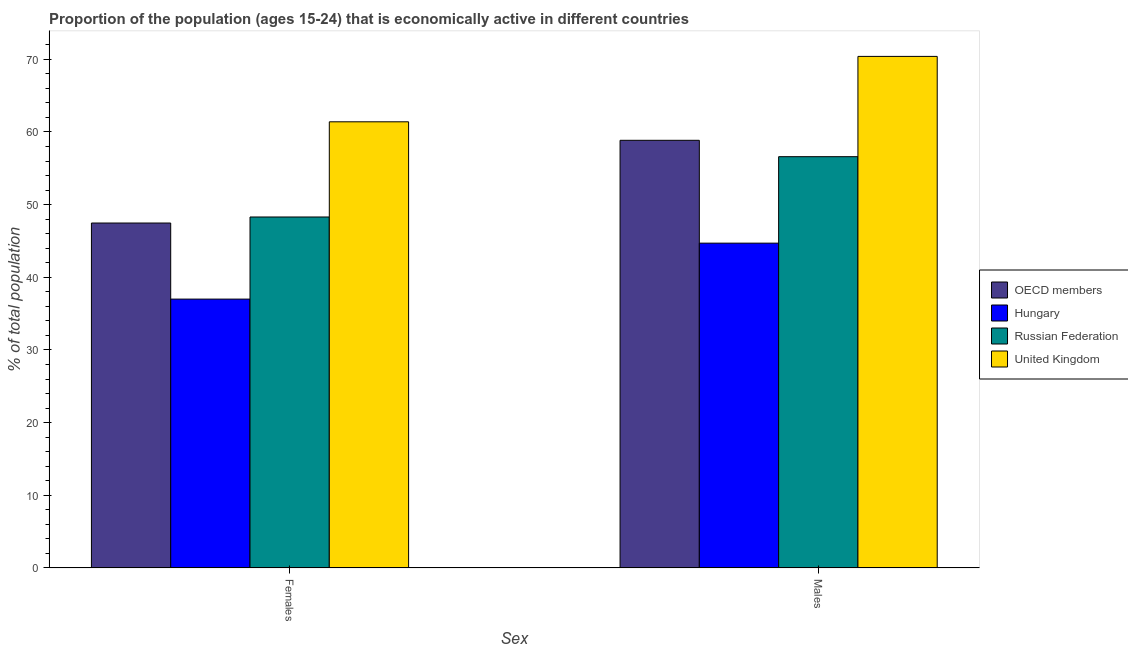How many different coloured bars are there?
Your answer should be very brief. 4. Are the number of bars per tick equal to the number of legend labels?
Keep it short and to the point. Yes. Are the number of bars on each tick of the X-axis equal?
Offer a very short reply. Yes. How many bars are there on the 1st tick from the left?
Keep it short and to the point. 4. What is the label of the 1st group of bars from the left?
Offer a terse response. Females. What is the percentage of economically active male population in OECD members?
Make the answer very short. 58.85. Across all countries, what is the maximum percentage of economically active male population?
Your answer should be very brief. 70.4. In which country was the percentage of economically active female population minimum?
Provide a succinct answer. Hungary. What is the total percentage of economically active female population in the graph?
Your response must be concise. 194.17. What is the difference between the percentage of economically active female population in Russian Federation and that in Hungary?
Ensure brevity in your answer.  11.3. What is the difference between the percentage of economically active female population in United Kingdom and the percentage of economically active male population in Russian Federation?
Your answer should be very brief. 4.8. What is the average percentage of economically active female population per country?
Keep it short and to the point. 48.54. What is the difference between the percentage of economically active female population and percentage of economically active male population in OECD members?
Ensure brevity in your answer.  -11.38. In how many countries, is the percentage of economically active male population greater than 10 %?
Make the answer very short. 4. What is the ratio of the percentage of economically active female population in OECD members to that in United Kingdom?
Give a very brief answer. 0.77. Is the percentage of economically active female population in Hungary less than that in Russian Federation?
Your answer should be compact. Yes. What does the 2nd bar from the left in Males represents?
Make the answer very short. Hungary. How many bars are there?
Your answer should be very brief. 8. Are all the bars in the graph horizontal?
Make the answer very short. No. How many countries are there in the graph?
Offer a very short reply. 4. Does the graph contain any zero values?
Your answer should be compact. No. Where does the legend appear in the graph?
Your answer should be very brief. Center right. What is the title of the graph?
Your answer should be very brief. Proportion of the population (ages 15-24) that is economically active in different countries. What is the label or title of the X-axis?
Offer a terse response. Sex. What is the label or title of the Y-axis?
Offer a terse response. % of total population. What is the % of total population of OECD members in Females?
Ensure brevity in your answer.  47.47. What is the % of total population in Russian Federation in Females?
Offer a very short reply. 48.3. What is the % of total population of United Kingdom in Females?
Your answer should be compact. 61.4. What is the % of total population in OECD members in Males?
Offer a very short reply. 58.85. What is the % of total population of Hungary in Males?
Ensure brevity in your answer.  44.7. What is the % of total population in Russian Federation in Males?
Your answer should be compact. 56.6. What is the % of total population of United Kingdom in Males?
Your answer should be very brief. 70.4. Across all Sex, what is the maximum % of total population in OECD members?
Your response must be concise. 58.85. Across all Sex, what is the maximum % of total population in Hungary?
Give a very brief answer. 44.7. Across all Sex, what is the maximum % of total population in Russian Federation?
Provide a succinct answer. 56.6. Across all Sex, what is the maximum % of total population of United Kingdom?
Your answer should be compact. 70.4. Across all Sex, what is the minimum % of total population of OECD members?
Offer a terse response. 47.47. Across all Sex, what is the minimum % of total population in Russian Federation?
Ensure brevity in your answer.  48.3. Across all Sex, what is the minimum % of total population in United Kingdom?
Provide a short and direct response. 61.4. What is the total % of total population in OECD members in the graph?
Provide a short and direct response. 106.32. What is the total % of total population of Hungary in the graph?
Provide a short and direct response. 81.7. What is the total % of total population of Russian Federation in the graph?
Offer a terse response. 104.9. What is the total % of total population of United Kingdom in the graph?
Your answer should be very brief. 131.8. What is the difference between the % of total population in OECD members in Females and that in Males?
Make the answer very short. -11.38. What is the difference between the % of total population of Hungary in Females and that in Males?
Offer a very short reply. -7.7. What is the difference between the % of total population in United Kingdom in Females and that in Males?
Offer a very short reply. -9. What is the difference between the % of total population in OECD members in Females and the % of total population in Hungary in Males?
Offer a very short reply. 2.77. What is the difference between the % of total population of OECD members in Females and the % of total population of Russian Federation in Males?
Keep it short and to the point. -9.13. What is the difference between the % of total population in OECD members in Females and the % of total population in United Kingdom in Males?
Offer a terse response. -22.93. What is the difference between the % of total population in Hungary in Females and the % of total population in Russian Federation in Males?
Offer a terse response. -19.6. What is the difference between the % of total population in Hungary in Females and the % of total population in United Kingdom in Males?
Provide a short and direct response. -33.4. What is the difference between the % of total population in Russian Federation in Females and the % of total population in United Kingdom in Males?
Your response must be concise. -22.1. What is the average % of total population of OECD members per Sex?
Provide a succinct answer. 53.16. What is the average % of total population in Hungary per Sex?
Ensure brevity in your answer.  40.85. What is the average % of total population of Russian Federation per Sex?
Offer a very short reply. 52.45. What is the average % of total population of United Kingdom per Sex?
Keep it short and to the point. 65.9. What is the difference between the % of total population in OECD members and % of total population in Hungary in Females?
Your answer should be very brief. 10.47. What is the difference between the % of total population in OECD members and % of total population in Russian Federation in Females?
Offer a very short reply. -0.83. What is the difference between the % of total population in OECD members and % of total population in United Kingdom in Females?
Give a very brief answer. -13.93. What is the difference between the % of total population of Hungary and % of total population of Russian Federation in Females?
Your answer should be very brief. -11.3. What is the difference between the % of total population of Hungary and % of total population of United Kingdom in Females?
Your answer should be very brief. -24.4. What is the difference between the % of total population in Russian Federation and % of total population in United Kingdom in Females?
Offer a very short reply. -13.1. What is the difference between the % of total population in OECD members and % of total population in Hungary in Males?
Offer a terse response. 14.15. What is the difference between the % of total population in OECD members and % of total population in Russian Federation in Males?
Give a very brief answer. 2.25. What is the difference between the % of total population of OECD members and % of total population of United Kingdom in Males?
Your answer should be very brief. -11.55. What is the difference between the % of total population of Hungary and % of total population of United Kingdom in Males?
Offer a terse response. -25.7. What is the ratio of the % of total population in OECD members in Females to that in Males?
Your response must be concise. 0.81. What is the ratio of the % of total population in Hungary in Females to that in Males?
Your answer should be compact. 0.83. What is the ratio of the % of total population in Russian Federation in Females to that in Males?
Provide a succinct answer. 0.85. What is the ratio of the % of total population of United Kingdom in Females to that in Males?
Provide a succinct answer. 0.87. What is the difference between the highest and the second highest % of total population of OECD members?
Your answer should be very brief. 11.38. What is the difference between the highest and the second highest % of total population of Hungary?
Make the answer very short. 7.7. What is the difference between the highest and the lowest % of total population in OECD members?
Ensure brevity in your answer.  11.38. What is the difference between the highest and the lowest % of total population in Russian Federation?
Your response must be concise. 8.3. 